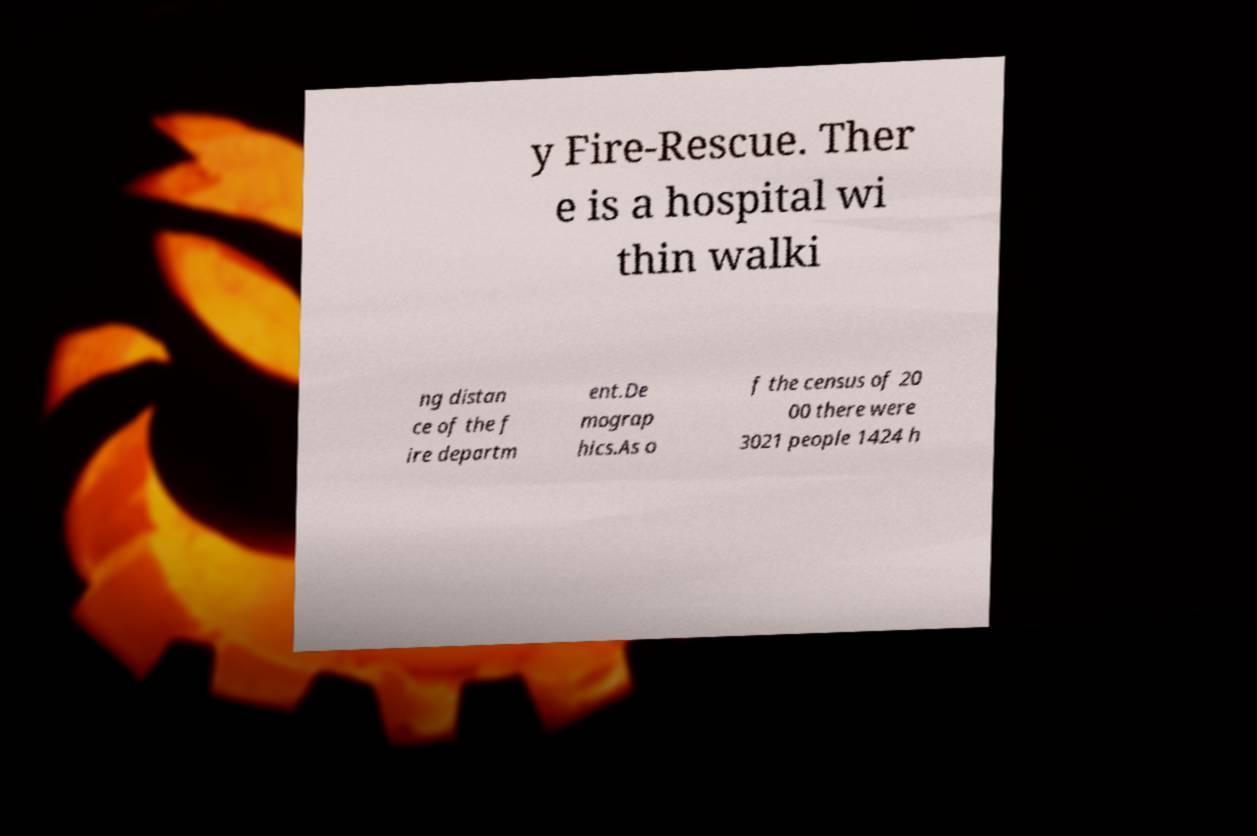Please identify and transcribe the text found in this image. y Fire-Rescue. Ther e is a hospital wi thin walki ng distan ce of the f ire departm ent.De mograp hics.As o f the census of 20 00 there were 3021 people 1424 h 